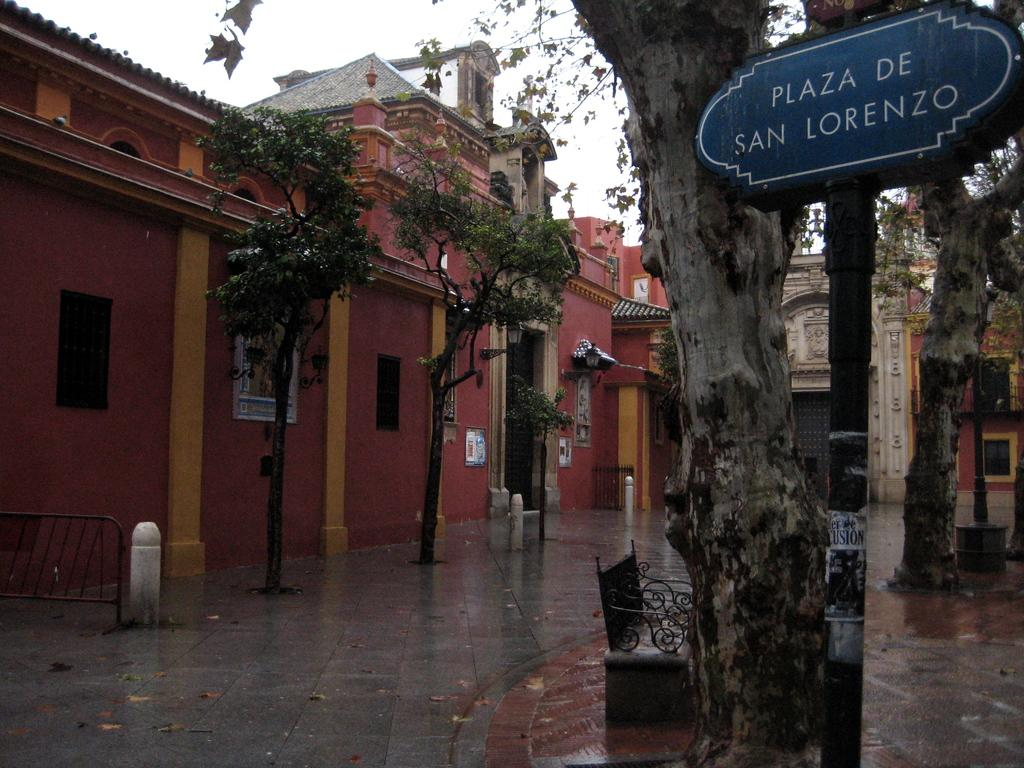<image>
Provide a brief description of the given image. A street scene with a sign in blue reading Plaza de San Lorenzo next to a tree 